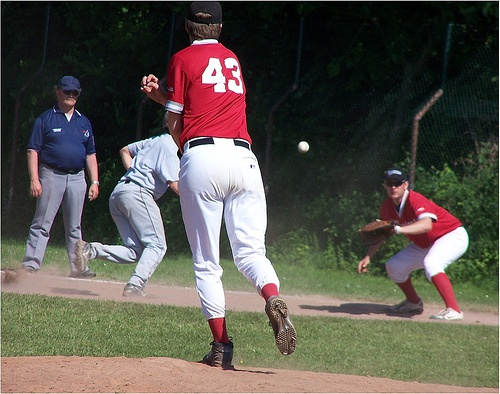Describe the objects in this image and their specific colors. I can see people in lightgray, white, black, brown, and maroon tones, people in lightgray, black, navy, darkgray, and gray tones, people in lightgray, lavender, gray, and darkgray tones, people in lightgray, maroon, white, black, and gray tones, and baseball glove in lightgray, black, brown, and maroon tones in this image. 